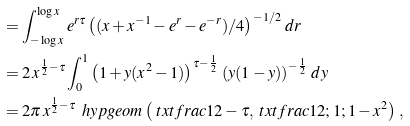Convert formula to latex. <formula><loc_0><loc_0><loc_500><loc_500>& \ = \int _ { - \log x } ^ { \log x } e ^ { r \tau } \left ( ( x + x ^ { - 1 } - e ^ { r } - e ^ { - r } ) / 4 \right ) ^ { - 1 / 2 } \, d r \\ & \ = 2 \, x ^ { \frac { 1 } { 2 } - \tau } \int _ { 0 } ^ { 1 } \left ( 1 + y ( x ^ { 2 } - 1 ) \right ) ^ { \tau - \frac { 1 } { 2 } } \, \left ( y ( 1 - y ) \right ) ^ { - \frac { 1 } { 2 } } \, d y \\ & \ = 2 \pi \, x ^ { \frac { 1 } { 2 } - \tau } \, \ h y p g e o m \left ( \ t x t f r a c 1 2 - \tau , \ t x t f r a c 1 2 ; 1 ; 1 - x ^ { 2 } \right ) \, ,</formula> 